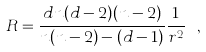Convert formula to latex. <formula><loc_0><loc_0><loc_500><loc_500>R = \frac { d n ( d - 2 ) ( n - 2 ) } { n ( n - 2 ) - ( d - 1 ) } \frac { 1 } { r ^ { 2 } } \ ,</formula> 